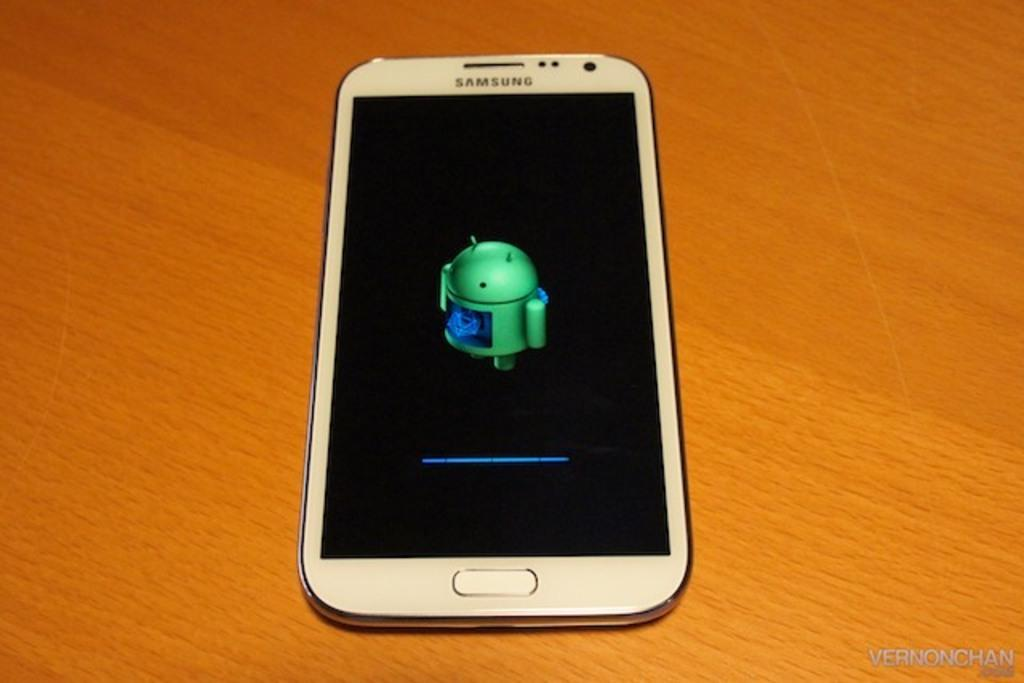<image>
Relay a brief, clear account of the picture shown. The front screen of a samsung branded phone that is currently being updated. 